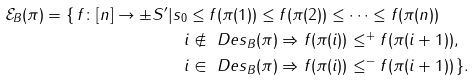<formula> <loc_0><loc_0><loc_500><loc_500>\mathcal { E } _ { B } ( \pi ) = \{ \, f \colon [ n ] \to \pm S ^ { \prime } & | s _ { 0 } \leq f ( \pi ( 1 ) ) \leq f ( \pi ( 2 ) ) \leq \cdots \leq f ( \pi ( n ) ) \\ & \quad i \notin \ D e s _ { B } ( \pi ) \Rightarrow f ( \pi ( i ) ) \leq ^ { + } f ( \pi ( i + 1 ) ) , \\ & \quad i \in \ D e s _ { B } ( \pi ) \Rightarrow f ( \pi ( i ) ) \leq ^ { - } f ( \pi ( i + 1 ) ) \, \} .</formula> 